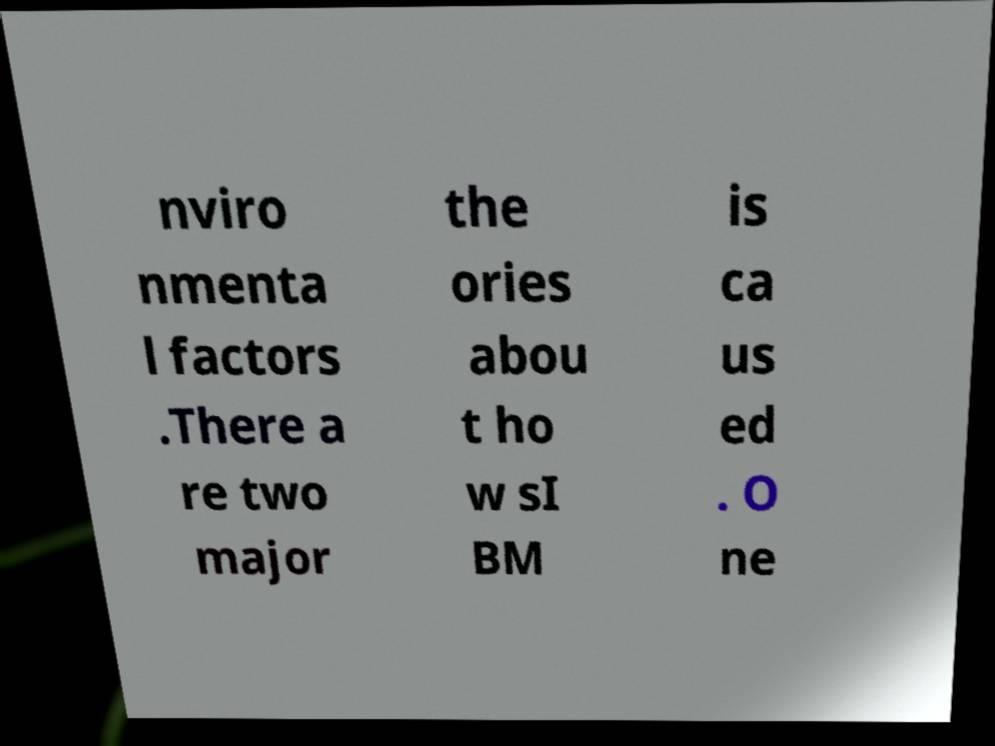I need the written content from this picture converted into text. Can you do that? nviro nmenta l factors .There a re two major the ories abou t ho w sI BM is ca us ed . O ne 